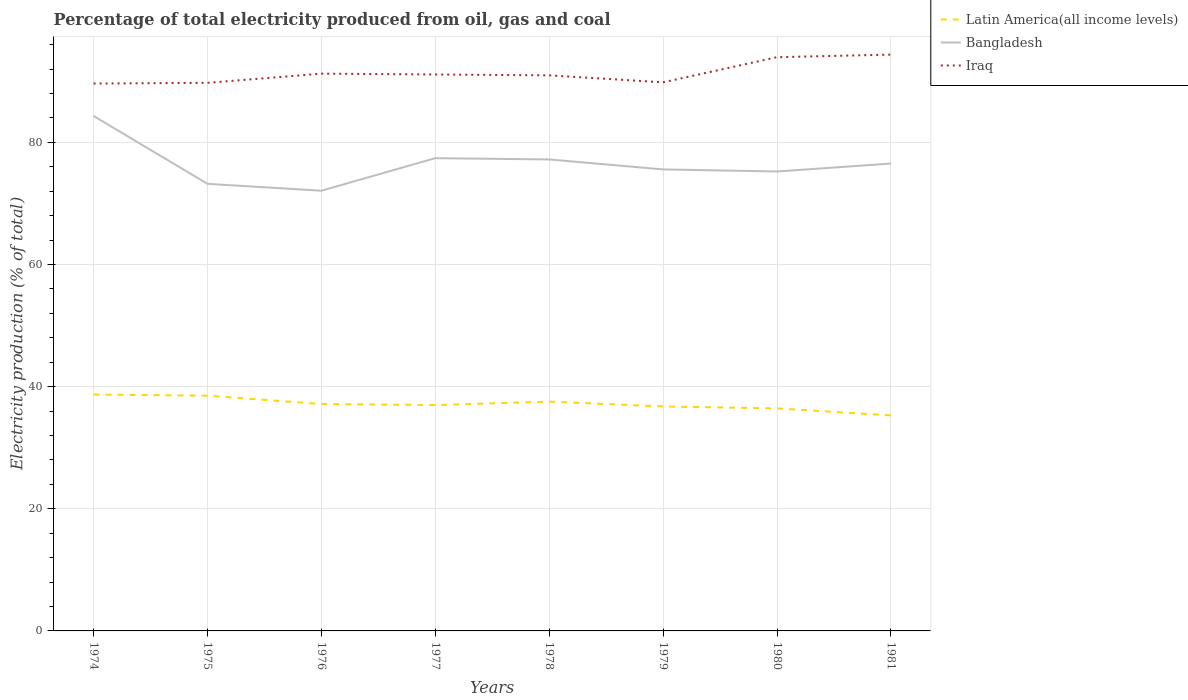How many different coloured lines are there?
Offer a terse response. 3. Is the number of lines equal to the number of legend labels?
Give a very brief answer. Yes. Across all years, what is the maximum electricity production in in Latin America(all income levels)?
Make the answer very short. 35.29. What is the total electricity production in in Latin America(all income levels) in the graph?
Provide a succinct answer. 0.55. What is the difference between the highest and the second highest electricity production in in Iraq?
Make the answer very short. 4.74. What is the difference between the highest and the lowest electricity production in in Bangladesh?
Provide a short and direct response. 4. How many years are there in the graph?
Your response must be concise. 8. What is the difference between two consecutive major ticks on the Y-axis?
Make the answer very short. 20. How are the legend labels stacked?
Make the answer very short. Vertical. What is the title of the graph?
Keep it short and to the point. Percentage of total electricity produced from oil, gas and coal. What is the label or title of the X-axis?
Ensure brevity in your answer.  Years. What is the label or title of the Y-axis?
Your response must be concise. Electricity production (% of total). What is the Electricity production (% of total) of Latin America(all income levels) in 1974?
Make the answer very short. 38.7. What is the Electricity production (% of total) of Bangladesh in 1974?
Your answer should be very brief. 84.31. What is the Electricity production (% of total) in Iraq in 1974?
Give a very brief answer. 89.62. What is the Electricity production (% of total) of Latin America(all income levels) in 1975?
Your response must be concise. 38.52. What is the Electricity production (% of total) of Bangladesh in 1975?
Provide a short and direct response. 73.2. What is the Electricity production (% of total) of Iraq in 1975?
Your answer should be compact. 89.74. What is the Electricity production (% of total) in Latin America(all income levels) in 1976?
Your answer should be compact. 37.15. What is the Electricity production (% of total) in Bangladesh in 1976?
Keep it short and to the point. 72.07. What is the Electricity production (% of total) of Iraq in 1976?
Offer a very short reply. 91.24. What is the Electricity production (% of total) in Latin America(all income levels) in 1977?
Offer a terse response. 36.98. What is the Electricity production (% of total) in Bangladesh in 1977?
Your response must be concise. 77.4. What is the Electricity production (% of total) in Iraq in 1977?
Keep it short and to the point. 91.11. What is the Electricity production (% of total) of Latin America(all income levels) in 1978?
Ensure brevity in your answer.  37.54. What is the Electricity production (% of total) of Bangladesh in 1978?
Make the answer very short. 77.2. What is the Electricity production (% of total) of Iraq in 1978?
Your answer should be compact. 90.96. What is the Electricity production (% of total) in Latin America(all income levels) in 1979?
Provide a succinct answer. 36.75. What is the Electricity production (% of total) in Bangladesh in 1979?
Your answer should be very brief. 75.56. What is the Electricity production (% of total) in Iraq in 1979?
Make the answer very short. 89.82. What is the Electricity production (% of total) of Latin America(all income levels) in 1980?
Keep it short and to the point. 36.44. What is the Electricity production (% of total) in Bangladesh in 1980?
Provide a succinct answer. 75.22. What is the Electricity production (% of total) of Iraq in 1980?
Your answer should be compact. 93.94. What is the Electricity production (% of total) of Latin America(all income levels) in 1981?
Your answer should be compact. 35.29. What is the Electricity production (% of total) of Bangladesh in 1981?
Offer a terse response. 76.52. What is the Electricity production (% of total) of Iraq in 1981?
Make the answer very short. 94.36. Across all years, what is the maximum Electricity production (% of total) in Latin America(all income levels)?
Your answer should be compact. 38.7. Across all years, what is the maximum Electricity production (% of total) in Bangladesh?
Your answer should be compact. 84.31. Across all years, what is the maximum Electricity production (% of total) of Iraq?
Make the answer very short. 94.36. Across all years, what is the minimum Electricity production (% of total) of Latin America(all income levels)?
Provide a succinct answer. 35.29. Across all years, what is the minimum Electricity production (% of total) in Bangladesh?
Your answer should be compact. 72.07. Across all years, what is the minimum Electricity production (% of total) in Iraq?
Offer a very short reply. 89.62. What is the total Electricity production (% of total) in Latin America(all income levels) in the graph?
Give a very brief answer. 297.36. What is the total Electricity production (% of total) in Bangladesh in the graph?
Keep it short and to the point. 611.5. What is the total Electricity production (% of total) in Iraq in the graph?
Provide a succinct answer. 730.79. What is the difference between the Electricity production (% of total) in Latin America(all income levels) in 1974 and that in 1975?
Your response must be concise. 0.19. What is the difference between the Electricity production (% of total) of Bangladesh in 1974 and that in 1975?
Offer a very short reply. 11.11. What is the difference between the Electricity production (% of total) of Iraq in 1974 and that in 1975?
Make the answer very short. -0.12. What is the difference between the Electricity production (% of total) of Latin America(all income levels) in 1974 and that in 1976?
Your answer should be very brief. 1.55. What is the difference between the Electricity production (% of total) of Bangladesh in 1974 and that in 1976?
Offer a very short reply. 12.24. What is the difference between the Electricity production (% of total) of Iraq in 1974 and that in 1976?
Provide a succinct answer. -1.61. What is the difference between the Electricity production (% of total) in Latin America(all income levels) in 1974 and that in 1977?
Your response must be concise. 1.72. What is the difference between the Electricity production (% of total) in Bangladesh in 1974 and that in 1977?
Provide a short and direct response. 6.91. What is the difference between the Electricity production (% of total) in Iraq in 1974 and that in 1977?
Offer a very short reply. -1.48. What is the difference between the Electricity production (% of total) in Latin America(all income levels) in 1974 and that in 1978?
Offer a terse response. 1.16. What is the difference between the Electricity production (% of total) of Bangladesh in 1974 and that in 1978?
Your response must be concise. 7.12. What is the difference between the Electricity production (% of total) of Iraq in 1974 and that in 1978?
Your answer should be very brief. -1.34. What is the difference between the Electricity production (% of total) of Latin America(all income levels) in 1974 and that in 1979?
Offer a very short reply. 1.96. What is the difference between the Electricity production (% of total) of Bangladesh in 1974 and that in 1979?
Provide a succinct answer. 8.75. What is the difference between the Electricity production (% of total) of Iraq in 1974 and that in 1979?
Give a very brief answer. -0.2. What is the difference between the Electricity production (% of total) of Latin America(all income levels) in 1974 and that in 1980?
Your answer should be very brief. 2.27. What is the difference between the Electricity production (% of total) of Bangladesh in 1974 and that in 1980?
Your answer should be compact. 9.09. What is the difference between the Electricity production (% of total) in Iraq in 1974 and that in 1980?
Keep it short and to the point. -4.31. What is the difference between the Electricity production (% of total) of Latin America(all income levels) in 1974 and that in 1981?
Your answer should be very brief. 3.42. What is the difference between the Electricity production (% of total) in Bangladesh in 1974 and that in 1981?
Your answer should be very brief. 7.79. What is the difference between the Electricity production (% of total) of Iraq in 1974 and that in 1981?
Offer a terse response. -4.74. What is the difference between the Electricity production (% of total) of Latin America(all income levels) in 1975 and that in 1976?
Offer a very short reply. 1.36. What is the difference between the Electricity production (% of total) in Bangladesh in 1975 and that in 1976?
Provide a succinct answer. 1.13. What is the difference between the Electricity production (% of total) of Iraq in 1975 and that in 1976?
Give a very brief answer. -1.5. What is the difference between the Electricity production (% of total) in Latin America(all income levels) in 1975 and that in 1977?
Offer a very short reply. 1.54. What is the difference between the Electricity production (% of total) in Bangladesh in 1975 and that in 1977?
Offer a terse response. -4.2. What is the difference between the Electricity production (% of total) in Iraq in 1975 and that in 1977?
Your answer should be compact. -1.37. What is the difference between the Electricity production (% of total) of Latin America(all income levels) in 1975 and that in 1978?
Keep it short and to the point. 0.97. What is the difference between the Electricity production (% of total) of Bangladesh in 1975 and that in 1978?
Offer a very short reply. -3.99. What is the difference between the Electricity production (% of total) in Iraq in 1975 and that in 1978?
Provide a succinct answer. -1.22. What is the difference between the Electricity production (% of total) of Latin America(all income levels) in 1975 and that in 1979?
Your response must be concise. 1.77. What is the difference between the Electricity production (% of total) of Bangladesh in 1975 and that in 1979?
Offer a very short reply. -2.36. What is the difference between the Electricity production (% of total) in Iraq in 1975 and that in 1979?
Offer a very short reply. -0.08. What is the difference between the Electricity production (% of total) in Latin America(all income levels) in 1975 and that in 1980?
Keep it short and to the point. 2.08. What is the difference between the Electricity production (% of total) in Bangladesh in 1975 and that in 1980?
Your answer should be very brief. -2.02. What is the difference between the Electricity production (% of total) in Iraq in 1975 and that in 1980?
Make the answer very short. -4.2. What is the difference between the Electricity production (% of total) of Latin America(all income levels) in 1975 and that in 1981?
Your response must be concise. 3.23. What is the difference between the Electricity production (% of total) in Bangladesh in 1975 and that in 1981?
Offer a terse response. -3.32. What is the difference between the Electricity production (% of total) of Iraq in 1975 and that in 1981?
Your answer should be compact. -4.62. What is the difference between the Electricity production (% of total) of Latin America(all income levels) in 1976 and that in 1977?
Offer a very short reply. 0.17. What is the difference between the Electricity production (% of total) of Bangladesh in 1976 and that in 1977?
Offer a terse response. -5.33. What is the difference between the Electricity production (% of total) of Iraq in 1976 and that in 1977?
Provide a short and direct response. 0.13. What is the difference between the Electricity production (% of total) in Latin America(all income levels) in 1976 and that in 1978?
Your response must be concise. -0.39. What is the difference between the Electricity production (% of total) in Bangladesh in 1976 and that in 1978?
Your response must be concise. -5.12. What is the difference between the Electricity production (% of total) of Iraq in 1976 and that in 1978?
Ensure brevity in your answer.  0.28. What is the difference between the Electricity production (% of total) of Latin America(all income levels) in 1976 and that in 1979?
Offer a terse response. 0.4. What is the difference between the Electricity production (% of total) of Bangladesh in 1976 and that in 1979?
Offer a very short reply. -3.49. What is the difference between the Electricity production (% of total) in Iraq in 1976 and that in 1979?
Make the answer very short. 1.42. What is the difference between the Electricity production (% of total) in Latin America(all income levels) in 1976 and that in 1980?
Keep it short and to the point. 0.72. What is the difference between the Electricity production (% of total) in Bangladesh in 1976 and that in 1980?
Provide a short and direct response. -3.15. What is the difference between the Electricity production (% of total) of Iraq in 1976 and that in 1980?
Provide a short and direct response. -2.7. What is the difference between the Electricity production (% of total) in Latin America(all income levels) in 1976 and that in 1981?
Offer a very short reply. 1.87. What is the difference between the Electricity production (% of total) in Bangladesh in 1976 and that in 1981?
Keep it short and to the point. -4.45. What is the difference between the Electricity production (% of total) of Iraq in 1976 and that in 1981?
Ensure brevity in your answer.  -3.12. What is the difference between the Electricity production (% of total) of Latin America(all income levels) in 1977 and that in 1978?
Offer a terse response. -0.56. What is the difference between the Electricity production (% of total) in Bangladesh in 1977 and that in 1978?
Provide a short and direct response. 0.21. What is the difference between the Electricity production (% of total) in Iraq in 1977 and that in 1978?
Keep it short and to the point. 0.14. What is the difference between the Electricity production (% of total) of Latin America(all income levels) in 1977 and that in 1979?
Offer a very short reply. 0.23. What is the difference between the Electricity production (% of total) of Bangladesh in 1977 and that in 1979?
Provide a short and direct response. 1.84. What is the difference between the Electricity production (% of total) in Iraq in 1977 and that in 1979?
Give a very brief answer. 1.28. What is the difference between the Electricity production (% of total) of Latin America(all income levels) in 1977 and that in 1980?
Provide a short and direct response. 0.55. What is the difference between the Electricity production (% of total) in Bangladesh in 1977 and that in 1980?
Make the answer very short. 2.18. What is the difference between the Electricity production (% of total) in Iraq in 1977 and that in 1980?
Make the answer very short. -2.83. What is the difference between the Electricity production (% of total) of Latin America(all income levels) in 1977 and that in 1981?
Your response must be concise. 1.69. What is the difference between the Electricity production (% of total) of Bangladesh in 1977 and that in 1981?
Keep it short and to the point. 0.88. What is the difference between the Electricity production (% of total) of Iraq in 1977 and that in 1981?
Offer a very short reply. -3.25. What is the difference between the Electricity production (% of total) of Latin America(all income levels) in 1978 and that in 1979?
Provide a succinct answer. 0.79. What is the difference between the Electricity production (% of total) of Bangladesh in 1978 and that in 1979?
Provide a succinct answer. 1.63. What is the difference between the Electricity production (% of total) in Iraq in 1978 and that in 1979?
Ensure brevity in your answer.  1.14. What is the difference between the Electricity production (% of total) in Latin America(all income levels) in 1978 and that in 1980?
Provide a succinct answer. 1.11. What is the difference between the Electricity production (% of total) in Bangladesh in 1978 and that in 1980?
Offer a terse response. 1.97. What is the difference between the Electricity production (% of total) in Iraq in 1978 and that in 1980?
Keep it short and to the point. -2.97. What is the difference between the Electricity production (% of total) in Latin America(all income levels) in 1978 and that in 1981?
Keep it short and to the point. 2.26. What is the difference between the Electricity production (% of total) of Bangladesh in 1978 and that in 1981?
Provide a short and direct response. 0.68. What is the difference between the Electricity production (% of total) in Iraq in 1978 and that in 1981?
Offer a very short reply. -3.4. What is the difference between the Electricity production (% of total) of Latin America(all income levels) in 1979 and that in 1980?
Ensure brevity in your answer.  0.31. What is the difference between the Electricity production (% of total) in Bangladesh in 1979 and that in 1980?
Keep it short and to the point. 0.34. What is the difference between the Electricity production (% of total) of Iraq in 1979 and that in 1980?
Your answer should be very brief. -4.12. What is the difference between the Electricity production (% of total) of Latin America(all income levels) in 1979 and that in 1981?
Offer a very short reply. 1.46. What is the difference between the Electricity production (% of total) in Bangladesh in 1979 and that in 1981?
Provide a succinct answer. -0.96. What is the difference between the Electricity production (% of total) in Iraq in 1979 and that in 1981?
Give a very brief answer. -4.54. What is the difference between the Electricity production (% of total) of Latin America(all income levels) in 1980 and that in 1981?
Make the answer very short. 1.15. What is the difference between the Electricity production (% of total) in Bangladesh in 1980 and that in 1981?
Offer a very short reply. -1.3. What is the difference between the Electricity production (% of total) of Iraq in 1980 and that in 1981?
Your answer should be compact. -0.42. What is the difference between the Electricity production (% of total) in Latin America(all income levels) in 1974 and the Electricity production (% of total) in Bangladesh in 1975?
Offer a very short reply. -34.5. What is the difference between the Electricity production (% of total) in Latin America(all income levels) in 1974 and the Electricity production (% of total) in Iraq in 1975?
Keep it short and to the point. -51.04. What is the difference between the Electricity production (% of total) in Bangladesh in 1974 and the Electricity production (% of total) in Iraq in 1975?
Give a very brief answer. -5.43. What is the difference between the Electricity production (% of total) in Latin America(all income levels) in 1974 and the Electricity production (% of total) in Bangladesh in 1976?
Your answer should be very brief. -33.37. What is the difference between the Electricity production (% of total) in Latin America(all income levels) in 1974 and the Electricity production (% of total) in Iraq in 1976?
Ensure brevity in your answer.  -52.54. What is the difference between the Electricity production (% of total) of Bangladesh in 1974 and the Electricity production (% of total) of Iraq in 1976?
Give a very brief answer. -6.93. What is the difference between the Electricity production (% of total) in Latin America(all income levels) in 1974 and the Electricity production (% of total) in Bangladesh in 1977?
Provide a short and direct response. -38.7. What is the difference between the Electricity production (% of total) in Latin America(all income levels) in 1974 and the Electricity production (% of total) in Iraq in 1977?
Your answer should be very brief. -52.4. What is the difference between the Electricity production (% of total) of Bangladesh in 1974 and the Electricity production (% of total) of Iraq in 1977?
Your response must be concise. -6.79. What is the difference between the Electricity production (% of total) in Latin America(all income levels) in 1974 and the Electricity production (% of total) in Bangladesh in 1978?
Offer a very short reply. -38.49. What is the difference between the Electricity production (% of total) of Latin America(all income levels) in 1974 and the Electricity production (% of total) of Iraq in 1978?
Your answer should be compact. -52.26. What is the difference between the Electricity production (% of total) in Bangladesh in 1974 and the Electricity production (% of total) in Iraq in 1978?
Your answer should be compact. -6.65. What is the difference between the Electricity production (% of total) of Latin America(all income levels) in 1974 and the Electricity production (% of total) of Bangladesh in 1979?
Ensure brevity in your answer.  -36.86. What is the difference between the Electricity production (% of total) of Latin America(all income levels) in 1974 and the Electricity production (% of total) of Iraq in 1979?
Your answer should be very brief. -51.12. What is the difference between the Electricity production (% of total) of Bangladesh in 1974 and the Electricity production (% of total) of Iraq in 1979?
Make the answer very short. -5.51. What is the difference between the Electricity production (% of total) in Latin America(all income levels) in 1974 and the Electricity production (% of total) in Bangladesh in 1980?
Provide a succinct answer. -36.52. What is the difference between the Electricity production (% of total) in Latin America(all income levels) in 1974 and the Electricity production (% of total) in Iraq in 1980?
Your answer should be compact. -55.24. What is the difference between the Electricity production (% of total) of Bangladesh in 1974 and the Electricity production (% of total) of Iraq in 1980?
Offer a very short reply. -9.63. What is the difference between the Electricity production (% of total) of Latin America(all income levels) in 1974 and the Electricity production (% of total) of Bangladesh in 1981?
Give a very brief answer. -37.82. What is the difference between the Electricity production (% of total) of Latin America(all income levels) in 1974 and the Electricity production (% of total) of Iraq in 1981?
Your answer should be compact. -55.66. What is the difference between the Electricity production (% of total) of Bangladesh in 1974 and the Electricity production (% of total) of Iraq in 1981?
Ensure brevity in your answer.  -10.05. What is the difference between the Electricity production (% of total) in Latin America(all income levels) in 1975 and the Electricity production (% of total) in Bangladesh in 1976?
Ensure brevity in your answer.  -33.56. What is the difference between the Electricity production (% of total) in Latin America(all income levels) in 1975 and the Electricity production (% of total) in Iraq in 1976?
Your answer should be compact. -52.72. What is the difference between the Electricity production (% of total) in Bangladesh in 1975 and the Electricity production (% of total) in Iraq in 1976?
Ensure brevity in your answer.  -18.04. What is the difference between the Electricity production (% of total) of Latin America(all income levels) in 1975 and the Electricity production (% of total) of Bangladesh in 1977?
Provide a succinct answer. -38.89. What is the difference between the Electricity production (% of total) in Latin America(all income levels) in 1975 and the Electricity production (% of total) in Iraq in 1977?
Make the answer very short. -52.59. What is the difference between the Electricity production (% of total) in Bangladesh in 1975 and the Electricity production (% of total) in Iraq in 1977?
Your answer should be very brief. -17.9. What is the difference between the Electricity production (% of total) in Latin America(all income levels) in 1975 and the Electricity production (% of total) in Bangladesh in 1978?
Keep it short and to the point. -38.68. What is the difference between the Electricity production (% of total) in Latin America(all income levels) in 1975 and the Electricity production (% of total) in Iraq in 1978?
Keep it short and to the point. -52.45. What is the difference between the Electricity production (% of total) in Bangladesh in 1975 and the Electricity production (% of total) in Iraq in 1978?
Provide a succinct answer. -17.76. What is the difference between the Electricity production (% of total) of Latin America(all income levels) in 1975 and the Electricity production (% of total) of Bangladesh in 1979?
Your answer should be very brief. -37.05. What is the difference between the Electricity production (% of total) in Latin America(all income levels) in 1975 and the Electricity production (% of total) in Iraq in 1979?
Your answer should be very brief. -51.31. What is the difference between the Electricity production (% of total) in Bangladesh in 1975 and the Electricity production (% of total) in Iraq in 1979?
Provide a short and direct response. -16.62. What is the difference between the Electricity production (% of total) in Latin America(all income levels) in 1975 and the Electricity production (% of total) in Bangladesh in 1980?
Provide a succinct answer. -36.71. What is the difference between the Electricity production (% of total) of Latin America(all income levels) in 1975 and the Electricity production (% of total) of Iraq in 1980?
Offer a terse response. -55.42. What is the difference between the Electricity production (% of total) in Bangladesh in 1975 and the Electricity production (% of total) in Iraq in 1980?
Make the answer very short. -20.74. What is the difference between the Electricity production (% of total) of Latin America(all income levels) in 1975 and the Electricity production (% of total) of Bangladesh in 1981?
Offer a very short reply. -38.01. What is the difference between the Electricity production (% of total) in Latin America(all income levels) in 1975 and the Electricity production (% of total) in Iraq in 1981?
Keep it short and to the point. -55.84. What is the difference between the Electricity production (% of total) in Bangladesh in 1975 and the Electricity production (% of total) in Iraq in 1981?
Provide a short and direct response. -21.16. What is the difference between the Electricity production (% of total) of Latin America(all income levels) in 1976 and the Electricity production (% of total) of Bangladesh in 1977?
Your response must be concise. -40.25. What is the difference between the Electricity production (% of total) in Latin America(all income levels) in 1976 and the Electricity production (% of total) in Iraq in 1977?
Keep it short and to the point. -53.95. What is the difference between the Electricity production (% of total) of Bangladesh in 1976 and the Electricity production (% of total) of Iraq in 1977?
Keep it short and to the point. -19.03. What is the difference between the Electricity production (% of total) of Latin America(all income levels) in 1976 and the Electricity production (% of total) of Bangladesh in 1978?
Ensure brevity in your answer.  -40.04. What is the difference between the Electricity production (% of total) in Latin America(all income levels) in 1976 and the Electricity production (% of total) in Iraq in 1978?
Offer a very short reply. -53.81. What is the difference between the Electricity production (% of total) of Bangladesh in 1976 and the Electricity production (% of total) of Iraq in 1978?
Offer a terse response. -18.89. What is the difference between the Electricity production (% of total) in Latin America(all income levels) in 1976 and the Electricity production (% of total) in Bangladesh in 1979?
Give a very brief answer. -38.41. What is the difference between the Electricity production (% of total) of Latin America(all income levels) in 1976 and the Electricity production (% of total) of Iraq in 1979?
Ensure brevity in your answer.  -52.67. What is the difference between the Electricity production (% of total) in Bangladesh in 1976 and the Electricity production (% of total) in Iraq in 1979?
Make the answer very short. -17.75. What is the difference between the Electricity production (% of total) in Latin America(all income levels) in 1976 and the Electricity production (% of total) in Bangladesh in 1980?
Keep it short and to the point. -38.07. What is the difference between the Electricity production (% of total) in Latin America(all income levels) in 1976 and the Electricity production (% of total) in Iraq in 1980?
Keep it short and to the point. -56.79. What is the difference between the Electricity production (% of total) in Bangladesh in 1976 and the Electricity production (% of total) in Iraq in 1980?
Offer a very short reply. -21.86. What is the difference between the Electricity production (% of total) in Latin America(all income levels) in 1976 and the Electricity production (% of total) in Bangladesh in 1981?
Keep it short and to the point. -39.37. What is the difference between the Electricity production (% of total) of Latin America(all income levels) in 1976 and the Electricity production (% of total) of Iraq in 1981?
Give a very brief answer. -57.21. What is the difference between the Electricity production (% of total) of Bangladesh in 1976 and the Electricity production (% of total) of Iraq in 1981?
Offer a very short reply. -22.28. What is the difference between the Electricity production (% of total) of Latin America(all income levels) in 1977 and the Electricity production (% of total) of Bangladesh in 1978?
Provide a succinct answer. -40.22. What is the difference between the Electricity production (% of total) of Latin America(all income levels) in 1977 and the Electricity production (% of total) of Iraq in 1978?
Give a very brief answer. -53.98. What is the difference between the Electricity production (% of total) in Bangladesh in 1977 and the Electricity production (% of total) in Iraq in 1978?
Offer a terse response. -13.56. What is the difference between the Electricity production (% of total) in Latin America(all income levels) in 1977 and the Electricity production (% of total) in Bangladesh in 1979?
Offer a very short reply. -38.58. What is the difference between the Electricity production (% of total) in Latin America(all income levels) in 1977 and the Electricity production (% of total) in Iraq in 1979?
Give a very brief answer. -52.84. What is the difference between the Electricity production (% of total) of Bangladesh in 1977 and the Electricity production (% of total) of Iraq in 1979?
Your response must be concise. -12.42. What is the difference between the Electricity production (% of total) of Latin America(all income levels) in 1977 and the Electricity production (% of total) of Bangladesh in 1980?
Make the answer very short. -38.24. What is the difference between the Electricity production (% of total) of Latin America(all income levels) in 1977 and the Electricity production (% of total) of Iraq in 1980?
Offer a very short reply. -56.96. What is the difference between the Electricity production (% of total) of Bangladesh in 1977 and the Electricity production (% of total) of Iraq in 1980?
Your answer should be very brief. -16.53. What is the difference between the Electricity production (% of total) in Latin America(all income levels) in 1977 and the Electricity production (% of total) in Bangladesh in 1981?
Offer a terse response. -39.54. What is the difference between the Electricity production (% of total) of Latin America(all income levels) in 1977 and the Electricity production (% of total) of Iraq in 1981?
Your response must be concise. -57.38. What is the difference between the Electricity production (% of total) of Bangladesh in 1977 and the Electricity production (% of total) of Iraq in 1981?
Offer a terse response. -16.95. What is the difference between the Electricity production (% of total) of Latin America(all income levels) in 1978 and the Electricity production (% of total) of Bangladesh in 1979?
Your answer should be compact. -38.02. What is the difference between the Electricity production (% of total) of Latin America(all income levels) in 1978 and the Electricity production (% of total) of Iraq in 1979?
Your answer should be compact. -52.28. What is the difference between the Electricity production (% of total) in Bangladesh in 1978 and the Electricity production (% of total) in Iraq in 1979?
Your answer should be very brief. -12.63. What is the difference between the Electricity production (% of total) in Latin America(all income levels) in 1978 and the Electricity production (% of total) in Bangladesh in 1980?
Your answer should be very brief. -37.68. What is the difference between the Electricity production (% of total) of Latin America(all income levels) in 1978 and the Electricity production (% of total) of Iraq in 1980?
Make the answer very short. -56.4. What is the difference between the Electricity production (% of total) of Bangladesh in 1978 and the Electricity production (% of total) of Iraq in 1980?
Give a very brief answer. -16.74. What is the difference between the Electricity production (% of total) of Latin America(all income levels) in 1978 and the Electricity production (% of total) of Bangladesh in 1981?
Offer a terse response. -38.98. What is the difference between the Electricity production (% of total) in Latin America(all income levels) in 1978 and the Electricity production (% of total) in Iraq in 1981?
Offer a terse response. -56.82. What is the difference between the Electricity production (% of total) in Bangladesh in 1978 and the Electricity production (% of total) in Iraq in 1981?
Offer a very short reply. -17.16. What is the difference between the Electricity production (% of total) of Latin America(all income levels) in 1979 and the Electricity production (% of total) of Bangladesh in 1980?
Ensure brevity in your answer.  -38.48. What is the difference between the Electricity production (% of total) in Latin America(all income levels) in 1979 and the Electricity production (% of total) in Iraq in 1980?
Make the answer very short. -57.19. What is the difference between the Electricity production (% of total) in Bangladesh in 1979 and the Electricity production (% of total) in Iraq in 1980?
Offer a terse response. -18.38. What is the difference between the Electricity production (% of total) of Latin America(all income levels) in 1979 and the Electricity production (% of total) of Bangladesh in 1981?
Your response must be concise. -39.77. What is the difference between the Electricity production (% of total) of Latin America(all income levels) in 1979 and the Electricity production (% of total) of Iraq in 1981?
Provide a short and direct response. -57.61. What is the difference between the Electricity production (% of total) of Bangladesh in 1979 and the Electricity production (% of total) of Iraq in 1981?
Keep it short and to the point. -18.8. What is the difference between the Electricity production (% of total) of Latin America(all income levels) in 1980 and the Electricity production (% of total) of Bangladesh in 1981?
Your answer should be compact. -40.09. What is the difference between the Electricity production (% of total) of Latin America(all income levels) in 1980 and the Electricity production (% of total) of Iraq in 1981?
Provide a short and direct response. -57.92. What is the difference between the Electricity production (% of total) in Bangladesh in 1980 and the Electricity production (% of total) in Iraq in 1981?
Offer a terse response. -19.14. What is the average Electricity production (% of total) in Latin America(all income levels) per year?
Provide a succinct answer. 37.17. What is the average Electricity production (% of total) in Bangladesh per year?
Your answer should be very brief. 76.44. What is the average Electricity production (% of total) in Iraq per year?
Your answer should be compact. 91.35. In the year 1974, what is the difference between the Electricity production (% of total) of Latin America(all income levels) and Electricity production (% of total) of Bangladesh?
Your answer should be very brief. -45.61. In the year 1974, what is the difference between the Electricity production (% of total) in Latin America(all income levels) and Electricity production (% of total) in Iraq?
Your answer should be very brief. -50.92. In the year 1974, what is the difference between the Electricity production (% of total) in Bangladesh and Electricity production (% of total) in Iraq?
Keep it short and to the point. -5.31. In the year 1975, what is the difference between the Electricity production (% of total) of Latin America(all income levels) and Electricity production (% of total) of Bangladesh?
Provide a short and direct response. -34.69. In the year 1975, what is the difference between the Electricity production (% of total) of Latin America(all income levels) and Electricity production (% of total) of Iraq?
Provide a short and direct response. -51.22. In the year 1975, what is the difference between the Electricity production (% of total) in Bangladesh and Electricity production (% of total) in Iraq?
Provide a succinct answer. -16.54. In the year 1976, what is the difference between the Electricity production (% of total) of Latin America(all income levels) and Electricity production (% of total) of Bangladesh?
Make the answer very short. -34.92. In the year 1976, what is the difference between the Electricity production (% of total) in Latin America(all income levels) and Electricity production (% of total) in Iraq?
Provide a short and direct response. -54.09. In the year 1976, what is the difference between the Electricity production (% of total) in Bangladesh and Electricity production (% of total) in Iraq?
Offer a very short reply. -19.16. In the year 1977, what is the difference between the Electricity production (% of total) in Latin America(all income levels) and Electricity production (% of total) in Bangladesh?
Your answer should be very brief. -40.42. In the year 1977, what is the difference between the Electricity production (% of total) in Latin America(all income levels) and Electricity production (% of total) in Iraq?
Provide a succinct answer. -54.13. In the year 1977, what is the difference between the Electricity production (% of total) in Bangladesh and Electricity production (% of total) in Iraq?
Your answer should be compact. -13.7. In the year 1978, what is the difference between the Electricity production (% of total) in Latin America(all income levels) and Electricity production (% of total) in Bangladesh?
Your answer should be very brief. -39.65. In the year 1978, what is the difference between the Electricity production (% of total) in Latin America(all income levels) and Electricity production (% of total) in Iraq?
Ensure brevity in your answer.  -53.42. In the year 1978, what is the difference between the Electricity production (% of total) of Bangladesh and Electricity production (% of total) of Iraq?
Make the answer very short. -13.77. In the year 1979, what is the difference between the Electricity production (% of total) in Latin America(all income levels) and Electricity production (% of total) in Bangladesh?
Your answer should be very brief. -38.81. In the year 1979, what is the difference between the Electricity production (% of total) in Latin America(all income levels) and Electricity production (% of total) in Iraq?
Your answer should be very brief. -53.07. In the year 1979, what is the difference between the Electricity production (% of total) of Bangladesh and Electricity production (% of total) of Iraq?
Offer a terse response. -14.26. In the year 1980, what is the difference between the Electricity production (% of total) in Latin America(all income levels) and Electricity production (% of total) in Bangladesh?
Offer a very short reply. -38.79. In the year 1980, what is the difference between the Electricity production (% of total) in Latin America(all income levels) and Electricity production (% of total) in Iraq?
Provide a succinct answer. -57.5. In the year 1980, what is the difference between the Electricity production (% of total) of Bangladesh and Electricity production (% of total) of Iraq?
Provide a succinct answer. -18.72. In the year 1981, what is the difference between the Electricity production (% of total) in Latin America(all income levels) and Electricity production (% of total) in Bangladesh?
Provide a succinct answer. -41.24. In the year 1981, what is the difference between the Electricity production (% of total) of Latin America(all income levels) and Electricity production (% of total) of Iraq?
Make the answer very short. -59.07. In the year 1981, what is the difference between the Electricity production (% of total) in Bangladesh and Electricity production (% of total) in Iraq?
Offer a terse response. -17.84. What is the ratio of the Electricity production (% of total) of Latin America(all income levels) in 1974 to that in 1975?
Your response must be concise. 1. What is the ratio of the Electricity production (% of total) of Bangladesh in 1974 to that in 1975?
Give a very brief answer. 1.15. What is the ratio of the Electricity production (% of total) of Latin America(all income levels) in 1974 to that in 1976?
Ensure brevity in your answer.  1.04. What is the ratio of the Electricity production (% of total) of Bangladesh in 1974 to that in 1976?
Your answer should be compact. 1.17. What is the ratio of the Electricity production (% of total) of Iraq in 1974 to that in 1976?
Offer a very short reply. 0.98. What is the ratio of the Electricity production (% of total) in Latin America(all income levels) in 1974 to that in 1977?
Your response must be concise. 1.05. What is the ratio of the Electricity production (% of total) in Bangladesh in 1974 to that in 1977?
Your response must be concise. 1.09. What is the ratio of the Electricity production (% of total) in Iraq in 1974 to that in 1977?
Your answer should be very brief. 0.98. What is the ratio of the Electricity production (% of total) of Latin America(all income levels) in 1974 to that in 1978?
Your answer should be very brief. 1.03. What is the ratio of the Electricity production (% of total) in Bangladesh in 1974 to that in 1978?
Ensure brevity in your answer.  1.09. What is the ratio of the Electricity production (% of total) of Iraq in 1974 to that in 1978?
Make the answer very short. 0.99. What is the ratio of the Electricity production (% of total) of Latin America(all income levels) in 1974 to that in 1979?
Your response must be concise. 1.05. What is the ratio of the Electricity production (% of total) in Bangladesh in 1974 to that in 1979?
Your response must be concise. 1.12. What is the ratio of the Electricity production (% of total) in Latin America(all income levels) in 1974 to that in 1980?
Offer a very short reply. 1.06. What is the ratio of the Electricity production (% of total) in Bangladesh in 1974 to that in 1980?
Ensure brevity in your answer.  1.12. What is the ratio of the Electricity production (% of total) in Iraq in 1974 to that in 1980?
Ensure brevity in your answer.  0.95. What is the ratio of the Electricity production (% of total) in Latin America(all income levels) in 1974 to that in 1981?
Give a very brief answer. 1.1. What is the ratio of the Electricity production (% of total) in Bangladesh in 1974 to that in 1981?
Your answer should be compact. 1.1. What is the ratio of the Electricity production (% of total) in Iraq in 1974 to that in 1981?
Keep it short and to the point. 0.95. What is the ratio of the Electricity production (% of total) of Latin America(all income levels) in 1975 to that in 1976?
Keep it short and to the point. 1.04. What is the ratio of the Electricity production (% of total) in Bangladesh in 1975 to that in 1976?
Offer a terse response. 1.02. What is the ratio of the Electricity production (% of total) of Iraq in 1975 to that in 1976?
Give a very brief answer. 0.98. What is the ratio of the Electricity production (% of total) in Latin America(all income levels) in 1975 to that in 1977?
Make the answer very short. 1.04. What is the ratio of the Electricity production (% of total) of Bangladesh in 1975 to that in 1977?
Your answer should be compact. 0.95. What is the ratio of the Electricity production (% of total) in Iraq in 1975 to that in 1977?
Your response must be concise. 0.98. What is the ratio of the Electricity production (% of total) of Latin America(all income levels) in 1975 to that in 1978?
Keep it short and to the point. 1.03. What is the ratio of the Electricity production (% of total) in Bangladesh in 1975 to that in 1978?
Keep it short and to the point. 0.95. What is the ratio of the Electricity production (% of total) in Iraq in 1975 to that in 1978?
Offer a terse response. 0.99. What is the ratio of the Electricity production (% of total) of Latin America(all income levels) in 1975 to that in 1979?
Your answer should be very brief. 1.05. What is the ratio of the Electricity production (% of total) in Bangladesh in 1975 to that in 1979?
Provide a short and direct response. 0.97. What is the ratio of the Electricity production (% of total) in Iraq in 1975 to that in 1979?
Provide a short and direct response. 1. What is the ratio of the Electricity production (% of total) in Latin America(all income levels) in 1975 to that in 1980?
Your response must be concise. 1.06. What is the ratio of the Electricity production (% of total) in Bangladesh in 1975 to that in 1980?
Your answer should be compact. 0.97. What is the ratio of the Electricity production (% of total) in Iraq in 1975 to that in 1980?
Make the answer very short. 0.96. What is the ratio of the Electricity production (% of total) of Latin America(all income levels) in 1975 to that in 1981?
Ensure brevity in your answer.  1.09. What is the ratio of the Electricity production (% of total) in Bangladesh in 1975 to that in 1981?
Ensure brevity in your answer.  0.96. What is the ratio of the Electricity production (% of total) in Iraq in 1975 to that in 1981?
Give a very brief answer. 0.95. What is the ratio of the Electricity production (% of total) of Latin America(all income levels) in 1976 to that in 1977?
Your answer should be very brief. 1. What is the ratio of the Electricity production (% of total) of Bangladesh in 1976 to that in 1977?
Provide a succinct answer. 0.93. What is the ratio of the Electricity production (% of total) in Iraq in 1976 to that in 1977?
Your response must be concise. 1. What is the ratio of the Electricity production (% of total) of Bangladesh in 1976 to that in 1978?
Provide a short and direct response. 0.93. What is the ratio of the Electricity production (% of total) in Latin America(all income levels) in 1976 to that in 1979?
Your answer should be very brief. 1.01. What is the ratio of the Electricity production (% of total) in Bangladesh in 1976 to that in 1979?
Offer a terse response. 0.95. What is the ratio of the Electricity production (% of total) of Iraq in 1976 to that in 1979?
Keep it short and to the point. 1.02. What is the ratio of the Electricity production (% of total) of Latin America(all income levels) in 1976 to that in 1980?
Your response must be concise. 1.02. What is the ratio of the Electricity production (% of total) in Bangladesh in 1976 to that in 1980?
Offer a very short reply. 0.96. What is the ratio of the Electricity production (% of total) in Iraq in 1976 to that in 1980?
Make the answer very short. 0.97. What is the ratio of the Electricity production (% of total) in Latin America(all income levels) in 1976 to that in 1981?
Ensure brevity in your answer.  1.05. What is the ratio of the Electricity production (% of total) of Bangladesh in 1976 to that in 1981?
Your answer should be very brief. 0.94. What is the ratio of the Electricity production (% of total) in Iraq in 1976 to that in 1981?
Your answer should be very brief. 0.97. What is the ratio of the Electricity production (% of total) in Latin America(all income levels) in 1977 to that in 1978?
Make the answer very short. 0.98. What is the ratio of the Electricity production (% of total) of Bangladesh in 1977 to that in 1979?
Offer a very short reply. 1.02. What is the ratio of the Electricity production (% of total) of Iraq in 1977 to that in 1979?
Make the answer very short. 1.01. What is the ratio of the Electricity production (% of total) of Iraq in 1977 to that in 1980?
Offer a terse response. 0.97. What is the ratio of the Electricity production (% of total) of Latin America(all income levels) in 1977 to that in 1981?
Offer a terse response. 1.05. What is the ratio of the Electricity production (% of total) in Bangladesh in 1977 to that in 1981?
Your answer should be compact. 1.01. What is the ratio of the Electricity production (% of total) in Iraq in 1977 to that in 1981?
Offer a terse response. 0.97. What is the ratio of the Electricity production (% of total) in Latin America(all income levels) in 1978 to that in 1979?
Offer a terse response. 1.02. What is the ratio of the Electricity production (% of total) of Bangladesh in 1978 to that in 1979?
Make the answer very short. 1.02. What is the ratio of the Electricity production (% of total) in Iraq in 1978 to that in 1979?
Offer a very short reply. 1.01. What is the ratio of the Electricity production (% of total) in Latin America(all income levels) in 1978 to that in 1980?
Your answer should be compact. 1.03. What is the ratio of the Electricity production (% of total) of Bangladesh in 1978 to that in 1980?
Ensure brevity in your answer.  1.03. What is the ratio of the Electricity production (% of total) in Iraq in 1978 to that in 1980?
Make the answer very short. 0.97. What is the ratio of the Electricity production (% of total) in Latin America(all income levels) in 1978 to that in 1981?
Your answer should be very brief. 1.06. What is the ratio of the Electricity production (% of total) of Bangladesh in 1978 to that in 1981?
Your response must be concise. 1.01. What is the ratio of the Electricity production (% of total) in Latin America(all income levels) in 1979 to that in 1980?
Your response must be concise. 1.01. What is the ratio of the Electricity production (% of total) of Bangladesh in 1979 to that in 1980?
Keep it short and to the point. 1. What is the ratio of the Electricity production (% of total) of Iraq in 1979 to that in 1980?
Ensure brevity in your answer.  0.96. What is the ratio of the Electricity production (% of total) in Latin America(all income levels) in 1979 to that in 1981?
Your response must be concise. 1.04. What is the ratio of the Electricity production (% of total) of Bangladesh in 1979 to that in 1981?
Give a very brief answer. 0.99. What is the ratio of the Electricity production (% of total) of Iraq in 1979 to that in 1981?
Provide a short and direct response. 0.95. What is the ratio of the Electricity production (% of total) in Latin America(all income levels) in 1980 to that in 1981?
Your answer should be compact. 1.03. What is the ratio of the Electricity production (% of total) of Bangladesh in 1980 to that in 1981?
Offer a very short reply. 0.98. What is the ratio of the Electricity production (% of total) of Iraq in 1980 to that in 1981?
Make the answer very short. 1. What is the difference between the highest and the second highest Electricity production (% of total) of Latin America(all income levels)?
Offer a terse response. 0.19. What is the difference between the highest and the second highest Electricity production (% of total) in Bangladesh?
Keep it short and to the point. 6.91. What is the difference between the highest and the second highest Electricity production (% of total) of Iraq?
Your answer should be very brief. 0.42. What is the difference between the highest and the lowest Electricity production (% of total) in Latin America(all income levels)?
Make the answer very short. 3.42. What is the difference between the highest and the lowest Electricity production (% of total) in Bangladesh?
Make the answer very short. 12.24. What is the difference between the highest and the lowest Electricity production (% of total) in Iraq?
Provide a short and direct response. 4.74. 